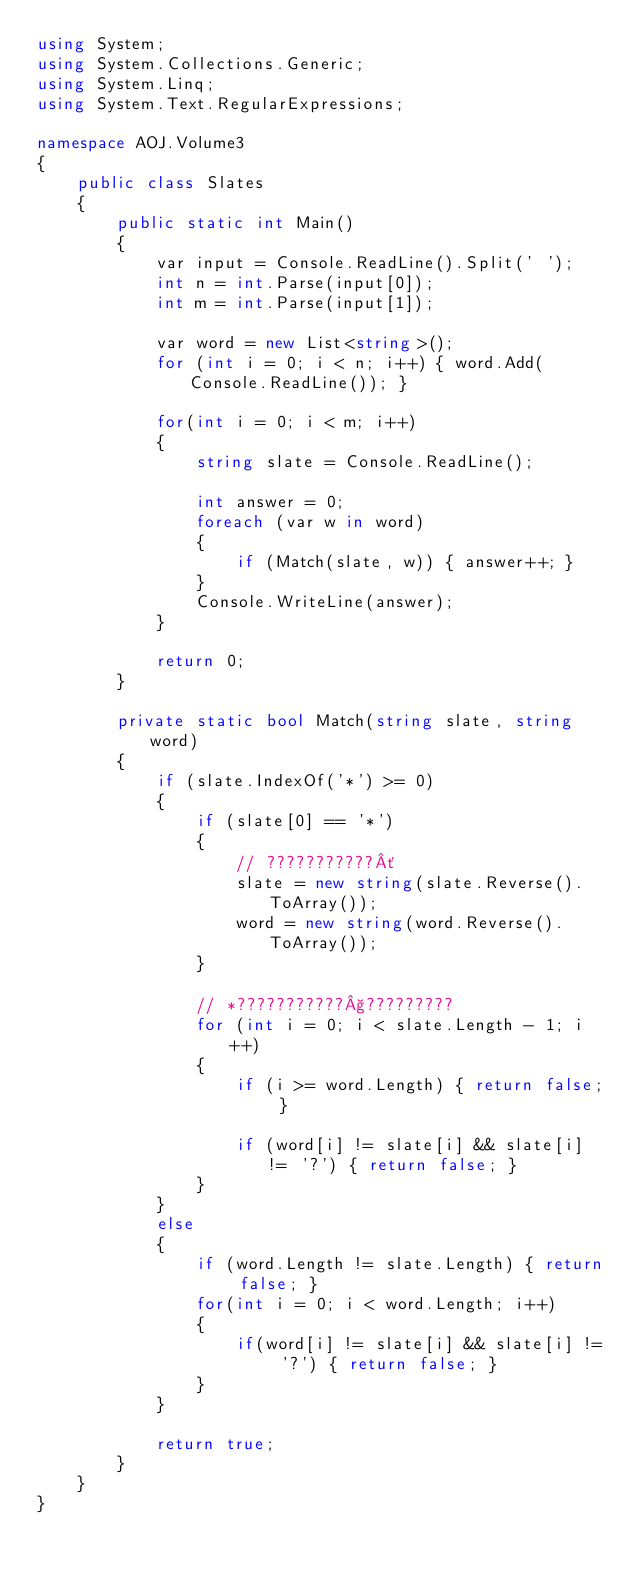<code> <loc_0><loc_0><loc_500><loc_500><_C#_>using System;
using System.Collections.Generic;
using System.Linq;
using System.Text.RegularExpressions;

namespace AOJ.Volume3
{
    public class Slates
    {
        public static int Main()
        {
            var input = Console.ReadLine().Split(' ');
            int n = int.Parse(input[0]);
            int m = int.Parse(input[1]);

            var word = new List<string>();
            for (int i = 0; i < n; i++) { word.Add(Console.ReadLine()); }

            for(int i = 0; i < m; i++)
            {
                string slate = Console.ReadLine();

                int answer = 0;
                foreach (var w in word)
                {
                    if (Match(slate, w)) { answer++; }
                }
                Console.WriteLine(answer);
            }

            return 0;
        }

        private static bool Match(string slate, string word)
        {
            if (slate.IndexOf('*') >= 0)
            {
                if (slate[0] == '*')
                {
                    // ???????????´
                    slate = new string(slate.Reverse().ToArray());
                    word = new string(word.Reverse().ToArray());
                }

                // *???????????§?????????
                for (int i = 0; i < slate.Length - 1; i++)
                {
                    if (i >= word.Length) { return false; }

                    if (word[i] != slate[i] && slate[i] != '?') { return false; }
                }
            }
            else
            {
                if (word.Length != slate.Length) { return false; }
                for(int i = 0; i < word.Length; i++)
                {
                    if(word[i] != slate[i] && slate[i] != '?') { return false; }
                }
            }

            return true;
        }
    }
}</code> 